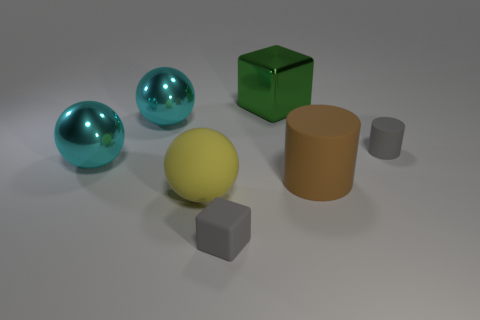Add 1 large purple rubber balls. How many objects exist? 8 Subtract all spheres. How many objects are left? 4 Add 5 purple metallic cylinders. How many purple metallic cylinders exist? 5 Subtract 0 purple spheres. How many objects are left? 7 Subtract all small yellow objects. Subtract all gray matte blocks. How many objects are left? 6 Add 1 small gray matte cylinders. How many small gray matte cylinders are left? 2 